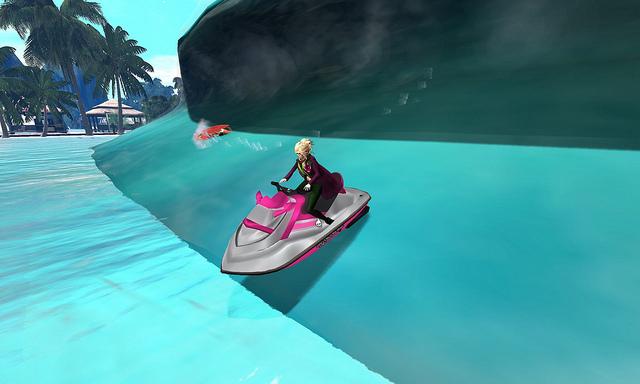Is the woman holding onto the handles?
Concise answer only. Yes. Is this a computer generated image?
Quick response, please. Yes. What type of trees are pictured?
Answer briefly. Palm. What is the person doing in the image?
Give a very brief answer. Jet skiing. 